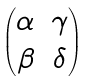Convert formula to latex. <formula><loc_0><loc_0><loc_500><loc_500>\begin{pmatrix} \alpha & \gamma \\ \beta & \delta \end{pmatrix}</formula> 